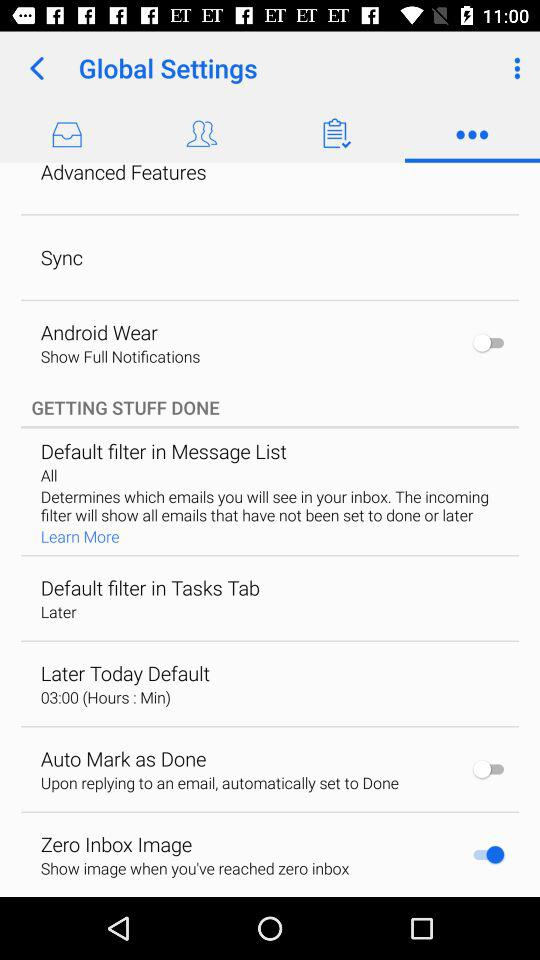What is the setting for "Default filter in Tasks Tab"? The setting is "Later". 